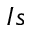Convert formula to latex. <formula><loc_0><loc_0><loc_500><loc_500>I s</formula> 